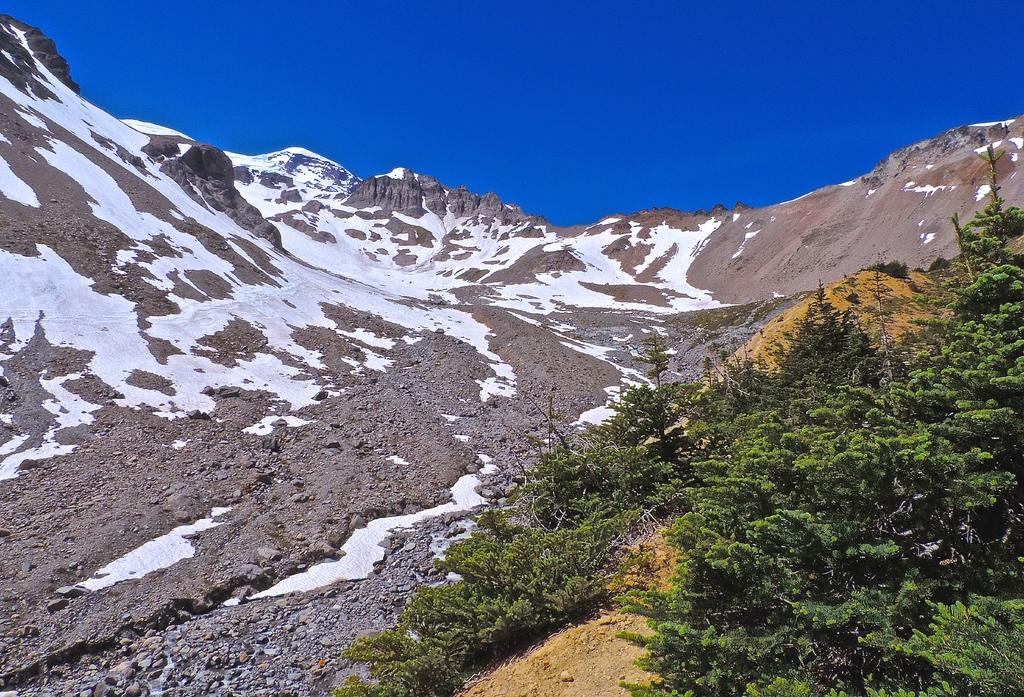What type of natural landscape is depicted in the image? The image features mountains. What is the weather like in the image? There is snow in the image, indicating a cold or wintry climate. What type of vegetation can be seen in the image? There are trees in the image. What color is the sky in the image? The sky is blue in the image. Can you see a person wearing a stocking in the image? There is no person or stocking present in the image. 